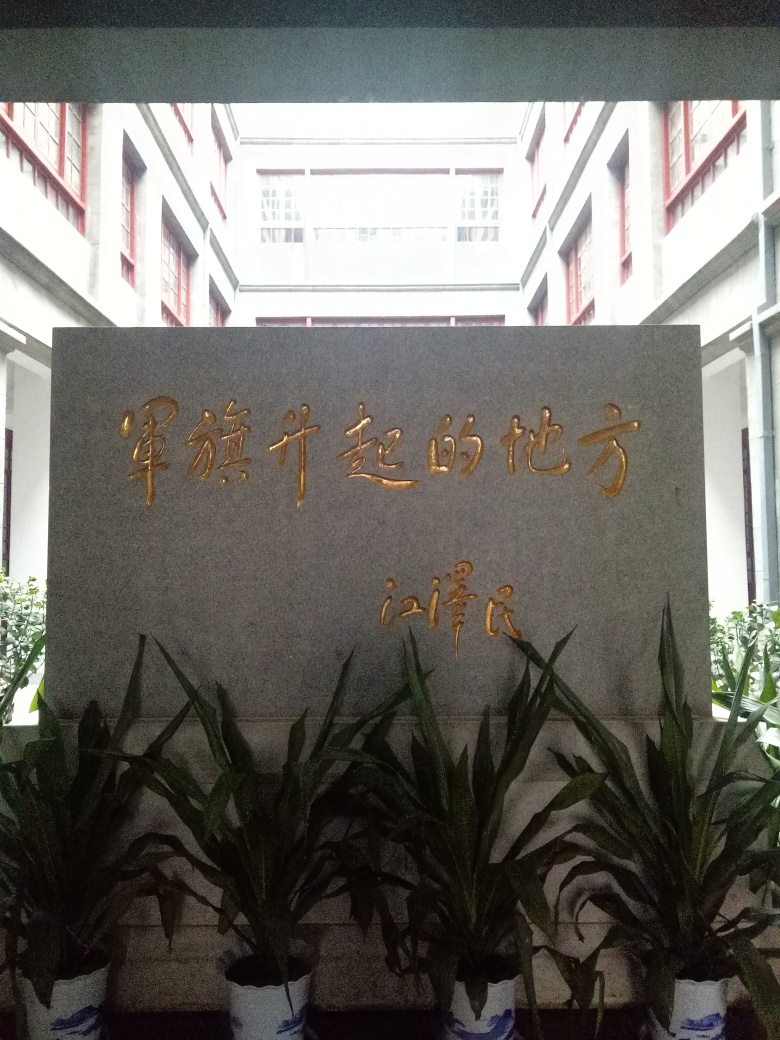Can you describe the plant life visible at the bottom of the image? The plants at the bottom of the image appear to be well-maintained green foliage, which could be a type of ornamental houseplant, like a Dracaena. They seem to be placed decoratively at the base of the monument or sign, likely to enhance the aesthetic appeal of the location. What do the plants contribute to the overall feel of the image? The plants introduce a natural and vibrant element to the scene, softening the stern appearance of the stone monument and the rigid structure of the building behind. They give a hint of life and serenity to the otherwise inanimate surroundings. 